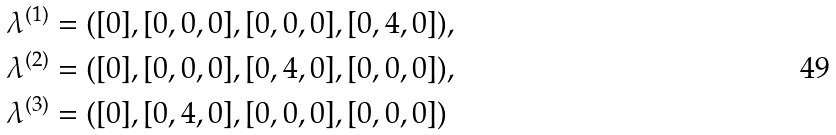<formula> <loc_0><loc_0><loc_500><loc_500>\lambda ^ { ( 1 ) } & = ( [ 0 ] , [ 0 , 0 , 0 ] , [ 0 , 0 , 0 ] , [ 0 , 4 , 0 ] ) , \\ \lambda ^ { ( 2 ) } & = ( [ 0 ] , [ 0 , 0 , 0 ] , [ 0 , 4 , 0 ] , [ 0 , 0 , 0 ] ) , \\ \lambda ^ { ( 3 ) } & = ( [ 0 ] , [ 0 , 4 , 0 ] , [ 0 , 0 , 0 ] , [ 0 , 0 , 0 ] )</formula> 